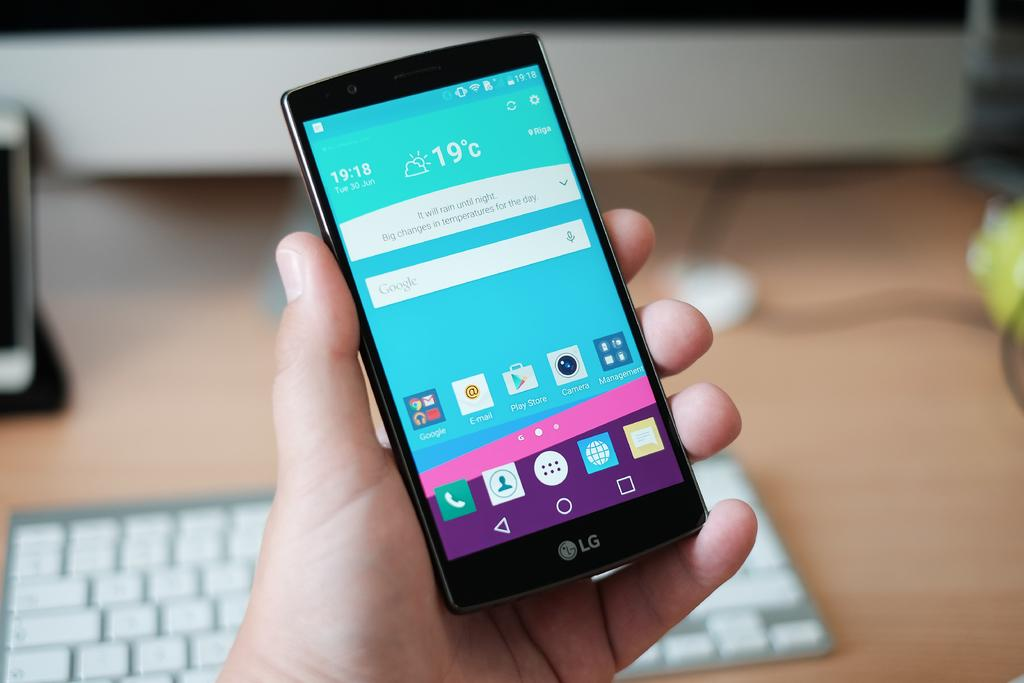<image>
Present a compact description of the photo's key features. A person is holding a black LG smartphone in front of a keyboard. 